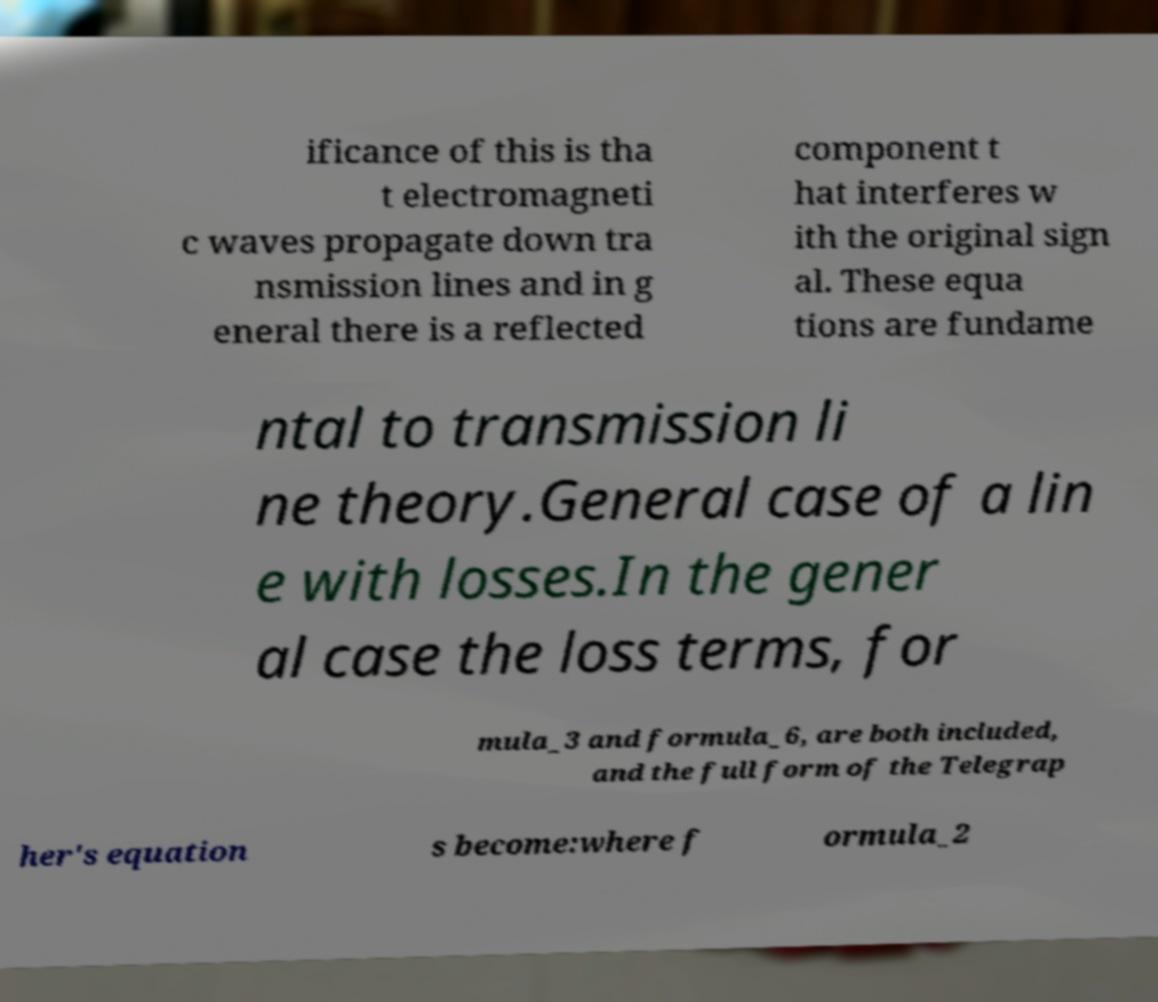Could you extract and type out the text from this image? ificance of this is tha t electromagneti c waves propagate down tra nsmission lines and in g eneral there is a reflected component t hat interferes w ith the original sign al. These equa tions are fundame ntal to transmission li ne theory.General case of a lin e with losses.In the gener al case the loss terms, for mula_3 and formula_6, are both included, and the full form of the Telegrap her's equation s become:where f ormula_2 